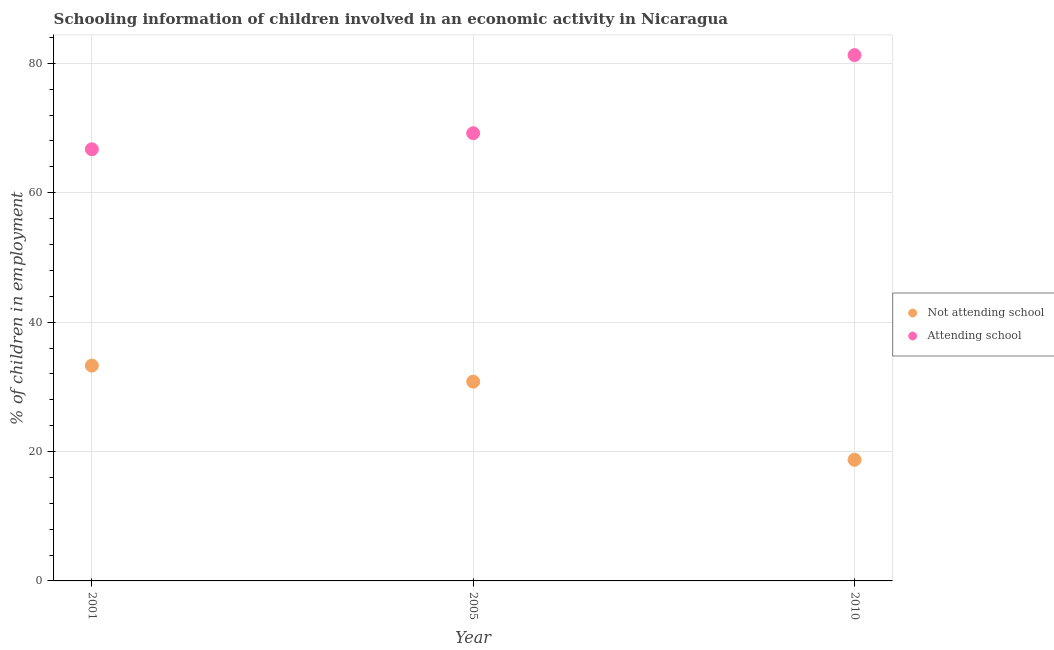How many different coloured dotlines are there?
Make the answer very short. 2. What is the percentage of employed children who are not attending school in 2001?
Keep it short and to the point. 33.28. Across all years, what is the maximum percentage of employed children who are not attending school?
Make the answer very short. 33.28. Across all years, what is the minimum percentage of employed children who are attending school?
Offer a very short reply. 66.72. In which year was the percentage of employed children who are not attending school maximum?
Your response must be concise. 2001. In which year was the percentage of employed children who are not attending school minimum?
Offer a terse response. 2010. What is the total percentage of employed children who are not attending school in the graph?
Your response must be concise. 82.81. What is the difference between the percentage of employed children who are attending school in 2005 and that in 2010?
Make the answer very short. -12.07. What is the difference between the percentage of employed children who are attending school in 2001 and the percentage of employed children who are not attending school in 2010?
Ensure brevity in your answer.  47.99. What is the average percentage of employed children who are not attending school per year?
Your response must be concise. 27.6. In the year 2005, what is the difference between the percentage of employed children who are attending school and percentage of employed children who are not attending school?
Offer a terse response. 38.4. In how many years, is the percentage of employed children who are attending school greater than 68 %?
Keep it short and to the point. 2. What is the ratio of the percentage of employed children who are attending school in 2001 to that in 2005?
Your answer should be compact. 0.96. Is the percentage of employed children who are not attending school in 2001 less than that in 2005?
Give a very brief answer. No. What is the difference between the highest and the second highest percentage of employed children who are not attending school?
Provide a short and direct response. 2.48. What is the difference between the highest and the lowest percentage of employed children who are attending school?
Provide a succinct answer. 14.55. In how many years, is the percentage of employed children who are attending school greater than the average percentage of employed children who are attending school taken over all years?
Provide a short and direct response. 1. Is the sum of the percentage of employed children who are not attending school in 2001 and 2010 greater than the maximum percentage of employed children who are attending school across all years?
Your answer should be compact. No. Is the percentage of employed children who are not attending school strictly less than the percentage of employed children who are attending school over the years?
Your answer should be very brief. Yes. How many dotlines are there?
Give a very brief answer. 2. What is the difference between two consecutive major ticks on the Y-axis?
Make the answer very short. 20. Does the graph contain any zero values?
Make the answer very short. No. Does the graph contain grids?
Keep it short and to the point. Yes. Where does the legend appear in the graph?
Provide a short and direct response. Center right. How many legend labels are there?
Keep it short and to the point. 2. What is the title of the graph?
Offer a terse response. Schooling information of children involved in an economic activity in Nicaragua. Does "Unregistered firms" appear as one of the legend labels in the graph?
Give a very brief answer. No. What is the label or title of the X-axis?
Give a very brief answer. Year. What is the label or title of the Y-axis?
Keep it short and to the point. % of children in employment. What is the % of children in employment of Not attending school in 2001?
Your response must be concise. 33.28. What is the % of children in employment in Attending school in 2001?
Your answer should be very brief. 66.72. What is the % of children in employment of Not attending school in 2005?
Make the answer very short. 30.8. What is the % of children in employment in Attending school in 2005?
Ensure brevity in your answer.  69.2. What is the % of children in employment of Not attending school in 2010?
Give a very brief answer. 18.73. What is the % of children in employment of Attending school in 2010?
Give a very brief answer. 81.27. Across all years, what is the maximum % of children in employment of Not attending school?
Your answer should be very brief. 33.28. Across all years, what is the maximum % of children in employment of Attending school?
Make the answer very short. 81.27. Across all years, what is the minimum % of children in employment of Not attending school?
Provide a short and direct response. 18.73. Across all years, what is the minimum % of children in employment in Attending school?
Ensure brevity in your answer.  66.72. What is the total % of children in employment in Not attending school in the graph?
Provide a short and direct response. 82.81. What is the total % of children in employment in Attending school in the graph?
Your answer should be compact. 217.19. What is the difference between the % of children in employment of Not attending school in 2001 and that in 2005?
Make the answer very short. 2.48. What is the difference between the % of children in employment of Attending school in 2001 and that in 2005?
Provide a short and direct response. -2.48. What is the difference between the % of children in employment of Not attending school in 2001 and that in 2010?
Offer a very short reply. 14.55. What is the difference between the % of children in employment of Attending school in 2001 and that in 2010?
Your response must be concise. -14.55. What is the difference between the % of children in employment in Not attending school in 2005 and that in 2010?
Your response must be concise. 12.07. What is the difference between the % of children in employment of Attending school in 2005 and that in 2010?
Provide a succinct answer. -12.07. What is the difference between the % of children in employment in Not attending school in 2001 and the % of children in employment in Attending school in 2005?
Your answer should be very brief. -35.92. What is the difference between the % of children in employment of Not attending school in 2001 and the % of children in employment of Attending school in 2010?
Your answer should be very brief. -47.99. What is the difference between the % of children in employment in Not attending school in 2005 and the % of children in employment in Attending school in 2010?
Offer a terse response. -50.47. What is the average % of children in employment of Not attending school per year?
Provide a short and direct response. 27.6. What is the average % of children in employment of Attending school per year?
Keep it short and to the point. 72.4. In the year 2001, what is the difference between the % of children in employment of Not attending school and % of children in employment of Attending school?
Make the answer very short. -33.44. In the year 2005, what is the difference between the % of children in employment of Not attending school and % of children in employment of Attending school?
Ensure brevity in your answer.  -38.4. In the year 2010, what is the difference between the % of children in employment of Not attending school and % of children in employment of Attending school?
Ensure brevity in your answer.  -62.55. What is the ratio of the % of children in employment in Not attending school in 2001 to that in 2005?
Your answer should be very brief. 1.08. What is the ratio of the % of children in employment in Attending school in 2001 to that in 2005?
Offer a very short reply. 0.96. What is the ratio of the % of children in employment of Not attending school in 2001 to that in 2010?
Provide a short and direct response. 1.78. What is the ratio of the % of children in employment in Attending school in 2001 to that in 2010?
Provide a succinct answer. 0.82. What is the ratio of the % of children in employment of Not attending school in 2005 to that in 2010?
Provide a short and direct response. 1.64. What is the ratio of the % of children in employment in Attending school in 2005 to that in 2010?
Your answer should be compact. 0.85. What is the difference between the highest and the second highest % of children in employment of Not attending school?
Offer a terse response. 2.48. What is the difference between the highest and the second highest % of children in employment of Attending school?
Your answer should be compact. 12.07. What is the difference between the highest and the lowest % of children in employment of Not attending school?
Keep it short and to the point. 14.55. What is the difference between the highest and the lowest % of children in employment in Attending school?
Your answer should be compact. 14.55. 